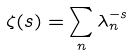<formula> <loc_0><loc_0><loc_500><loc_500>\zeta ( s ) = \sum _ { n } \lambda _ { n } ^ { - s }</formula> 